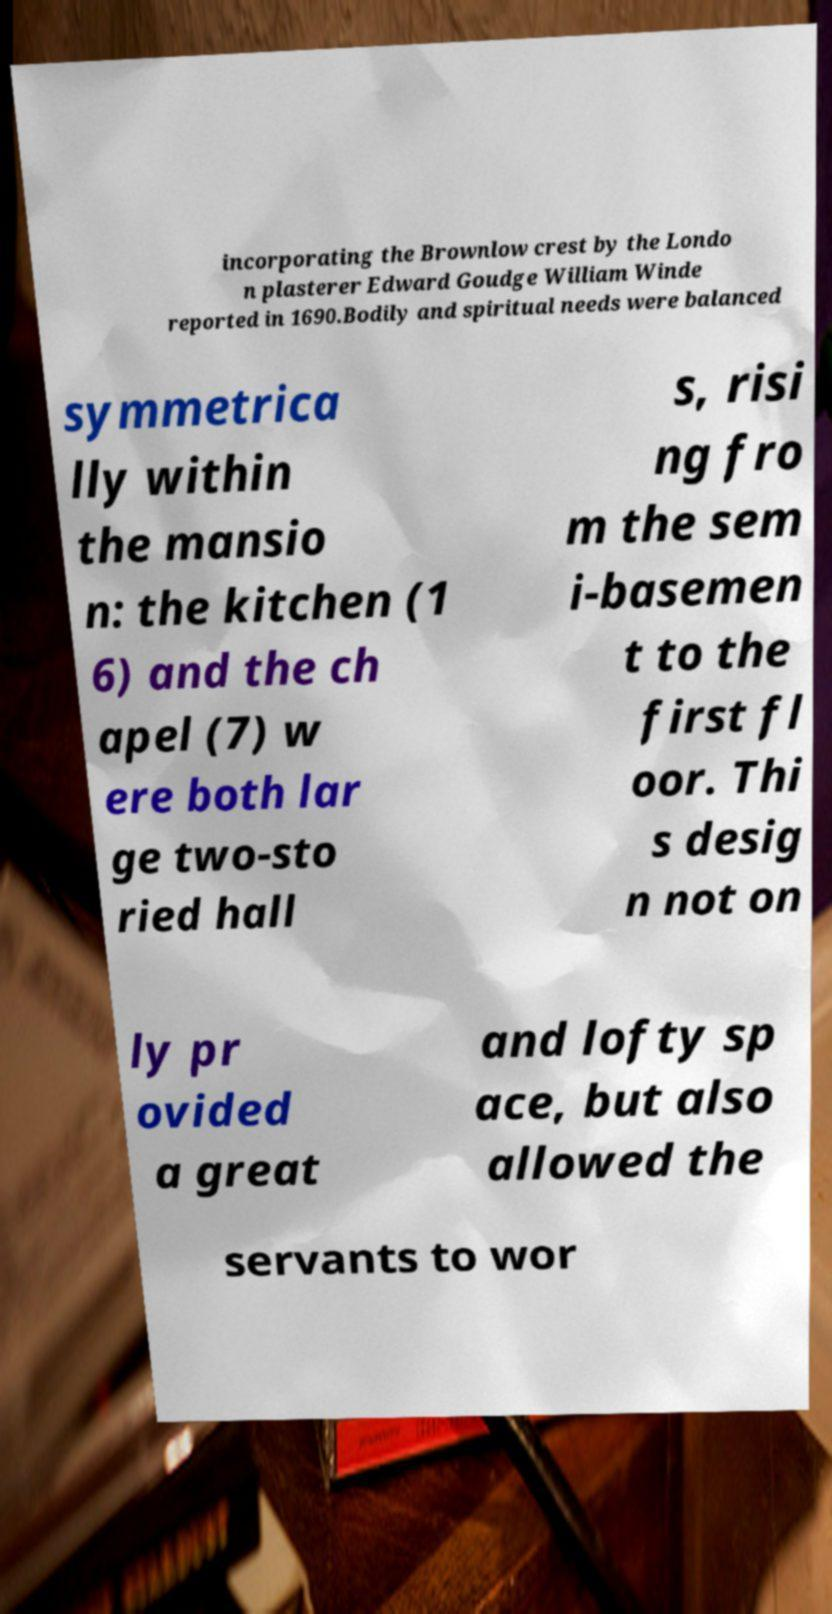Please read and relay the text visible in this image. What does it say? incorporating the Brownlow crest by the Londo n plasterer Edward Goudge William Winde reported in 1690.Bodily and spiritual needs were balanced symmetrica lly within the mansio n: the kitchen (1 6) and the ch apel (7) w ere both lar ge two-sto ried hall s, risi ng fro m the sem i-basemen t to the first fl oor. Thi s desig n not on ly pr ovided a great and lofty sp ace, but also allowed the servants to wor 